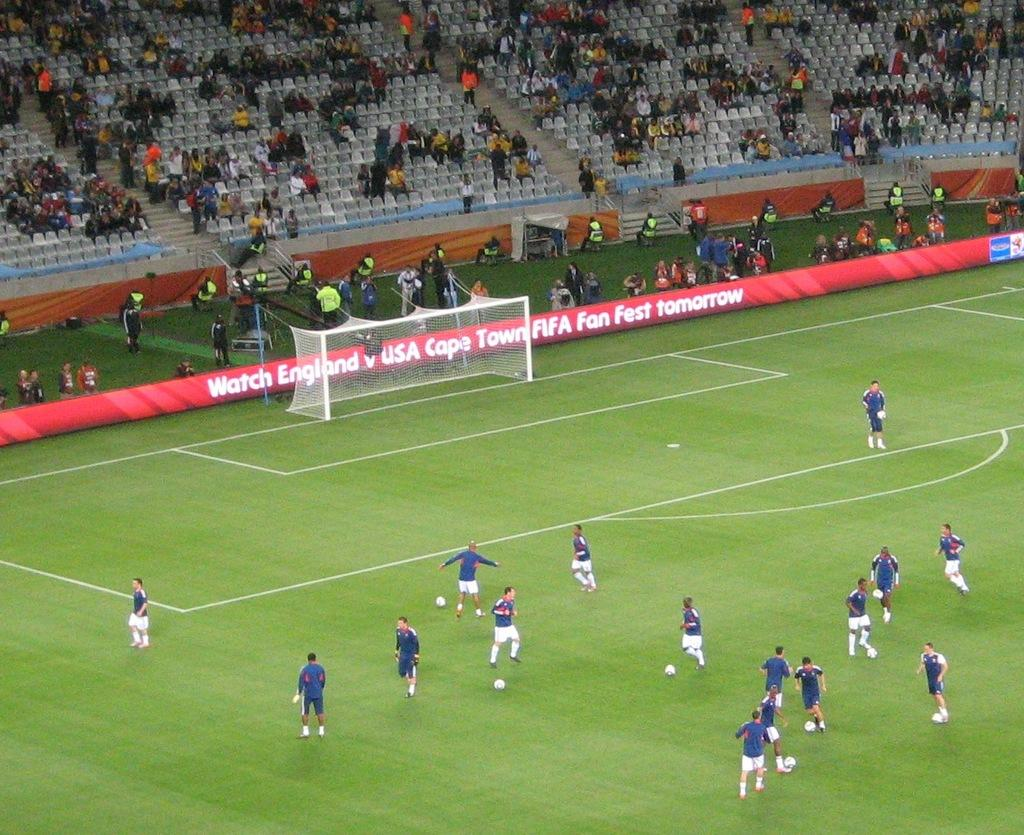<image>
Write a terse but informative summary of the picture. People playing soccer on a field with words that say "USA" in the back. 